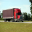What details can be observed about the semi-truck in this image that indicate its primary use? The semi-truck in the image is equipped with a large cargo container, suggesting its use in long-haul transportation. Its streamlined design hints at optimization for highway travel, and the presence of significant branding on the container indicates commercial use, likely for the transportation of goods across substantial distances. Additionally, the robust construction of the truck suggests its capability to handle substantial loads, aligning with its role in logistics and freight services. 